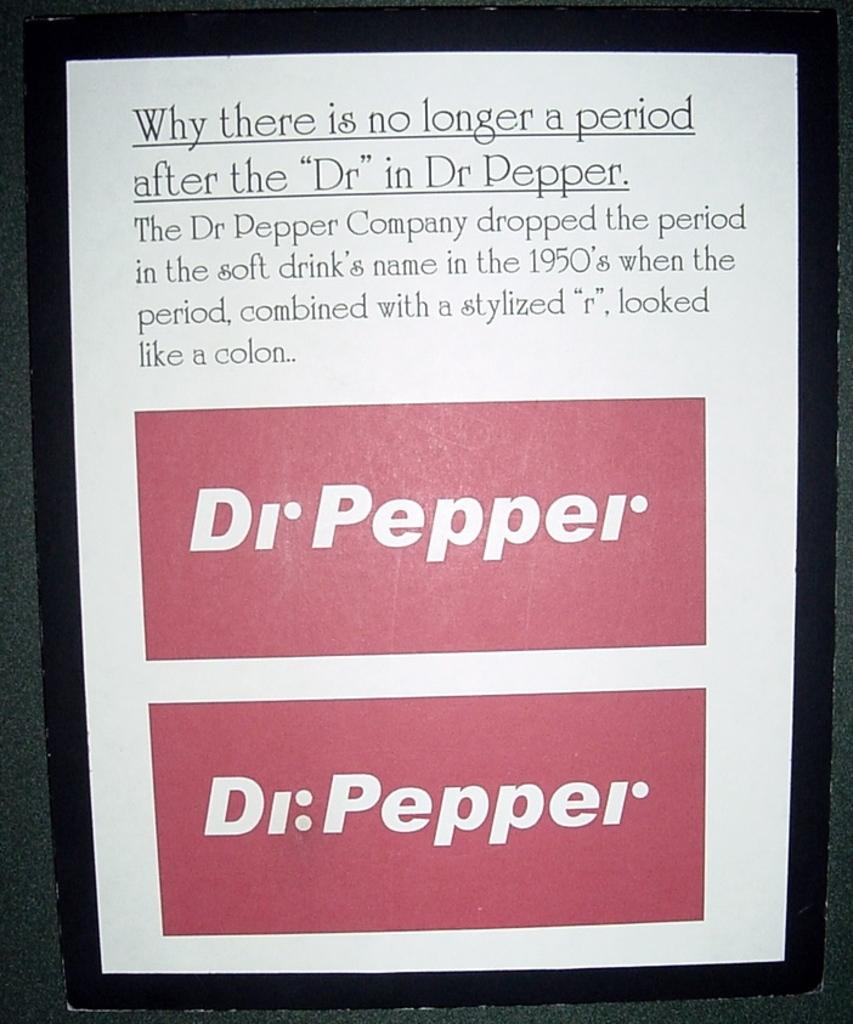<image>
Describe the image concisely. A poster board discusses why there is no longer a period after Dr in Dr Pepper 